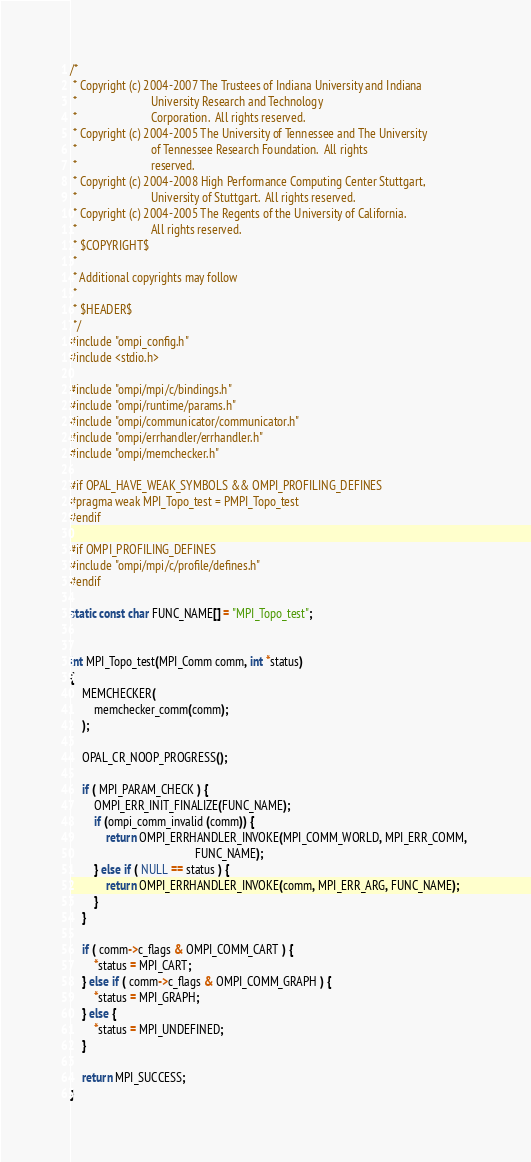<code> <loc_0><loc_0><loc_500><loc_500><_C_>/*
 * Copyright (c) 2004-2007 The Trustees of Indiana University and Indiana
 *                         University Research and Technology
 *                         Corporation.  All rights reserved.
 * Copyright (c) 2004-2005 The University of Tennessee and The University
 *                         of Tennessee Research Foundation.  All rights
 *                         reserved.
 * Copyright (c) 2004-2008 High Performance Computing Center Stuttgart, 
 *                         University of Stuttgart.  All rights reserved.
 * Copyright (c) 2004-2005 The Regents of the University of California.
 *                         All rights reserved.
 * $COPYRIGHT$
 * 
 * Additional copyrights may follow
 * 
 * $HEADER$
 */
#include "ompi_config.h"
#include <stdio.h>

#include "ompi/mpi/c/bindings.h"
#include "ompi/runtime/params.h"
#include "ompi/communicator/communicator.h"
#include "ompi/errhandler/errhandler.h"
#include "ompi/memchecker.h"

#if OPAL_HAVE_WEAK_SYMBOLS && OMPI_PROFILING_DEFINES
#pragma weak MPI_Topo_test = PMPI_Topo_test
#endif

#if OMPI_PROFILING_DEFINES
#include "ompi/mpi/c/profile/defines.h"
#endif

static const char FUNC_NAME[] = "MPI_Topo_test";


int MPI_Topo_test(MPI_Comm comm, int *status) 
{
    MEMCHECKER(
        memchecker_comm(comm);
    );

    OPAL_CR_NOOP_PROGRESS();

    if ( MPI_PARAM_CHECK ) {
        OMPI_ERR_INIT_FINALIZE(FUNC_NAME);
        if (ompi_comm_invalid (comm)) {
            return OMPI_ERRHANDLER_INVOKE(MPI_COMM_WORLD, MPI_ERR_COMM, 
                                          FUNC_NAME);
        } else if ( NULL == status ) {
            return OMPI_ERRHANDLER_INVOKE(comm, MPI_ERR_ARG, FUNC_NAME);
        }
    }

    if ( comm->c_flags & OMPI_COMM_CART ) {
        *status = MPI_CART;
    } else if ( comm->c_flags & OMPI_COMM_GRAPH ) {
        *status = MPI_GRAPH;
    } else {
        *status = MPI_UNDEFINED;
    }

    return MPI_SUCCESS;
}
</code> 